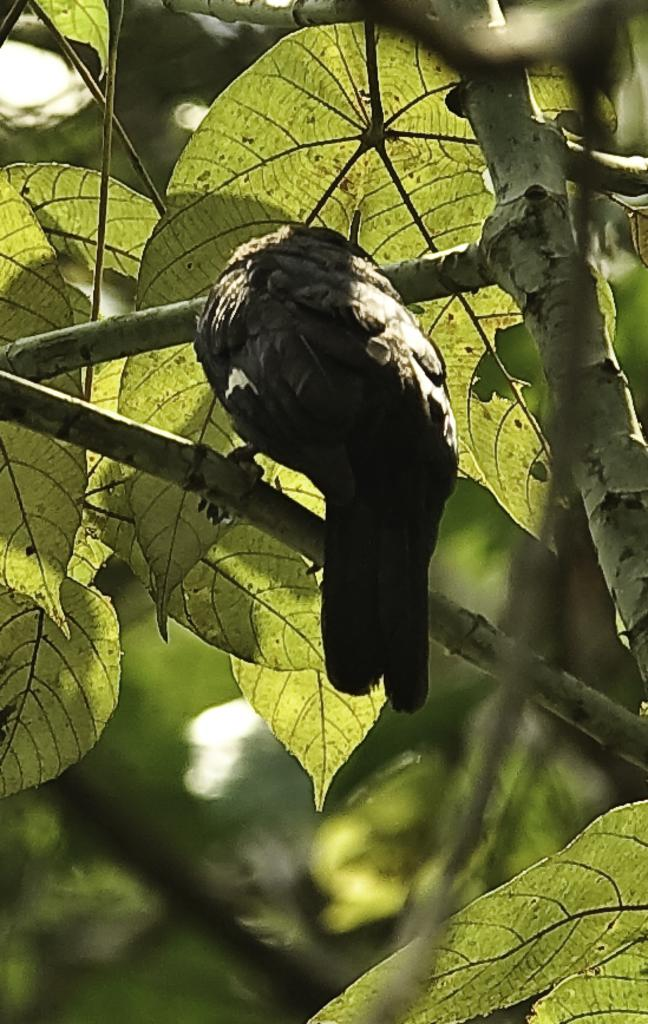What type of animal can be seen in the image? There is a bird in the image. Where is the bird located in the image? The bird is standing on the branch of a tree. What type of bomb is the bird holding in the image? There is no bomb present in the image; the bird is simply standing on the branch of a tree. 